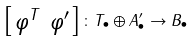<formula> <loc_0><loc_0><loc_500><loc_500>\left [ \begin{smallmatrix} \varphi ^ { T } & \varphi ^ { \prime } \end{smallmatrix} \right ] \colon T _ { \bullet } \oplus A ^ { \prime } _ { \bullet } \to B _ { \bullet }</formula> 